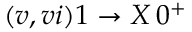Convert formula to latex. <formula><loc_0><loc_0><loc_500><loc_500>( v , v i ) 1 \to X \, 0 ^ { + }</formula> 